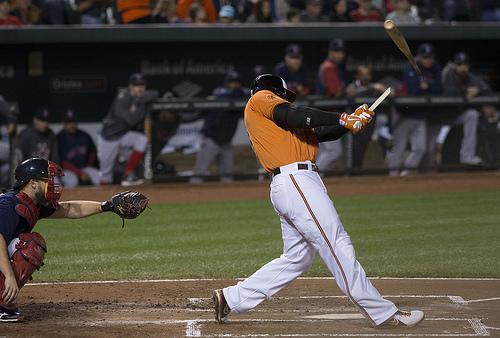How many players are holding a bat?
Give a very brief answer. 1. 